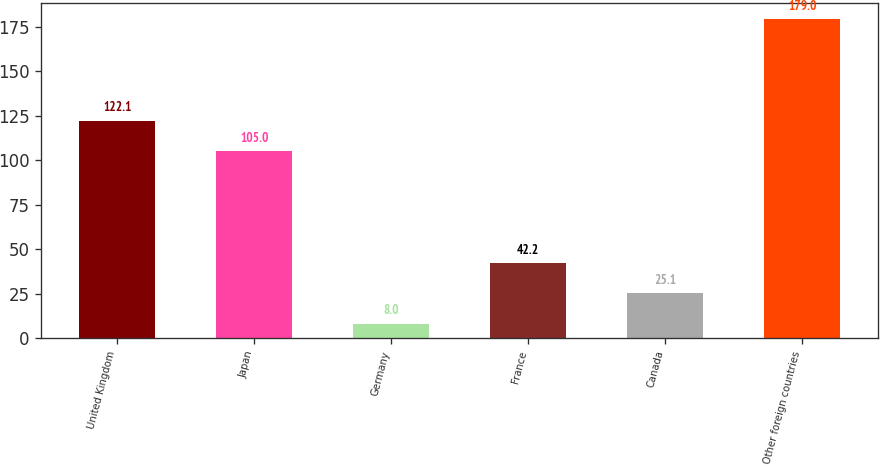<chart> <loc_0><loc_0><loc_500><loc_500><bar_chart><fcel>United Kingdom<fcel>Japan<fcel>Germany<fcel>France<fcel>Canada<fcel>Other foreign countries<nl><fcel>122.1<fcel>105<fcel>8<fcel>42.2<fcel>25.1<fcel>179<nl></chart> 